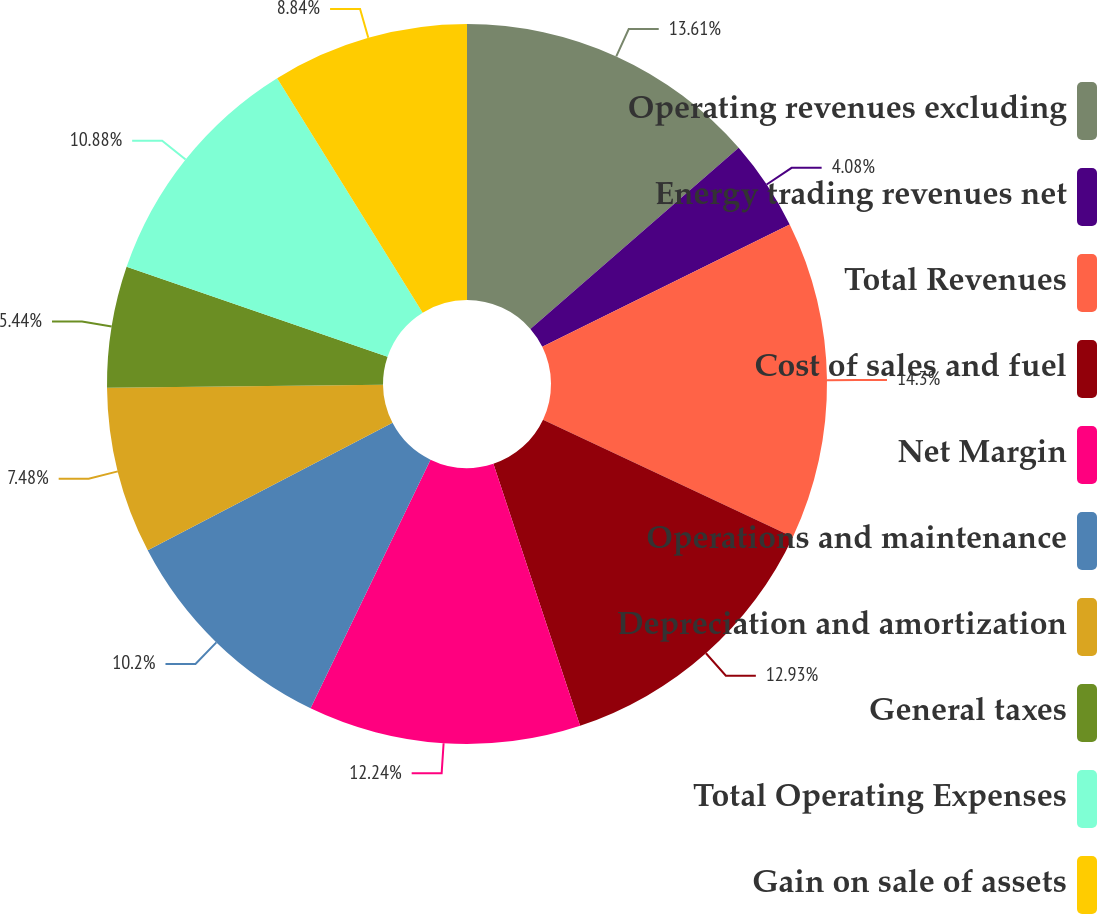Convert chart to OTSL. <chart><loc_0><loc_0><loc_500><loc_500><pie_chart><fcel>Operating revenues excluding<fcel>Energy trading revenues net<fcel>Total Revenues<fcel>Cost of sales and fuel<fcel>Net Margin<fcel>Operations and maintenance<fcel>Depreciation and amortization<fcel>General taxes<fcel>Total Operating Expenses<fcel>Gain on sale of assets<nl><fcel>13.61%<fcel>4.08%<fcel>14.29%<fcel>12.93%<fcel>12.24%<fcel>10.2%<fcel>7.48%<fcel>5.44%<fcel>10.88%<fcel>8.84%<nl></chart> 